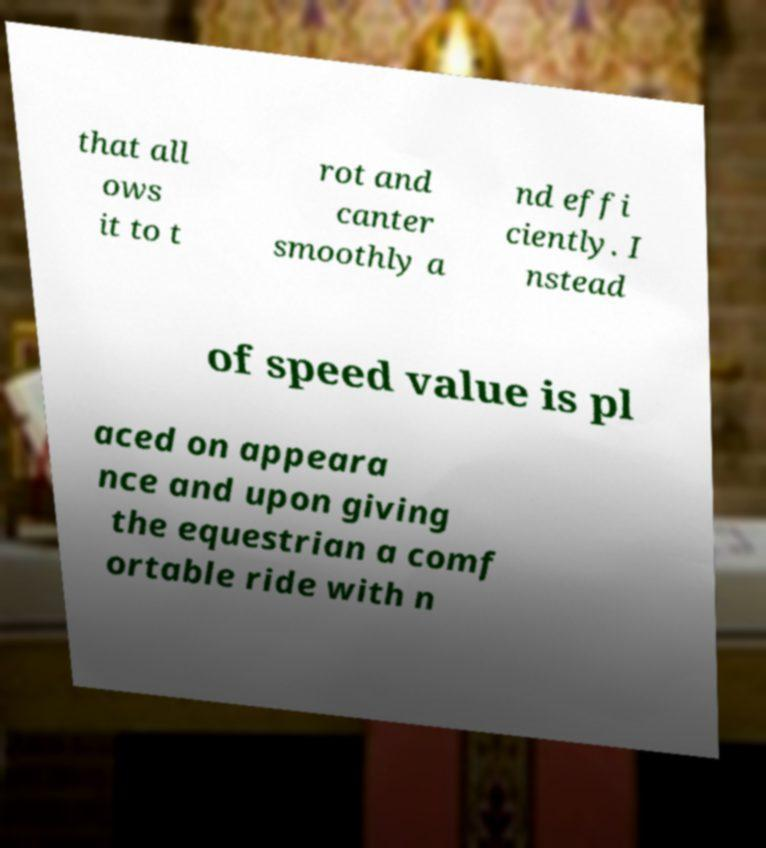For documentation purposes, I need the text within this image transcribed. Could you provide that? that all ows it to t rot and canter smoothly a nd effi ciently. I nstead of speed value is pl aced on appeara nce and upon giving the equestrian a comf ortable ride with n 